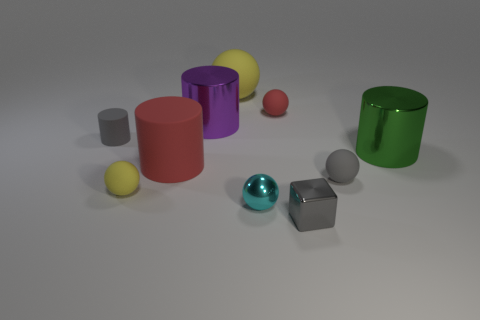What shape is the yellow thing that is behind the yellow rubber sphere that is in front of the big green metallic cylinder?
Your response must be concise. Sphere. Are there fewer red cylinders that are right of the green metallic object than large green shiny cylinders?
Offer a very short reply. Yes. What shape is the big green object?
Make the answer very short. Cylinder. There is a matte sphere that is left of the large yellow ball; how big is it?
Offer a terse response. Small. There is another shiny cylinder that is the same size as the green cylinder; what is its color?
Keep it short and to the point. Purple. Are there any other big balls of the same color as the large sphere?
Keep it short and to the point. No. Are there fewer large balls to the left of the big red object than big yellow things in front of the small red matte object?
Give a very brief answer. No. There is a large object that is both on the right side of the big purple cylinder and in front of the small red object; what material is it made of?
Ensure brevity in your answer.  Metal. Do the tiny yellow object and the small gray thing that is in front of the small yellow rubber sphere have the same shape?
Make the answer very short. No. How many other things are the same size as the gray matte ball?
Ensure brevity in your answer.  5. 